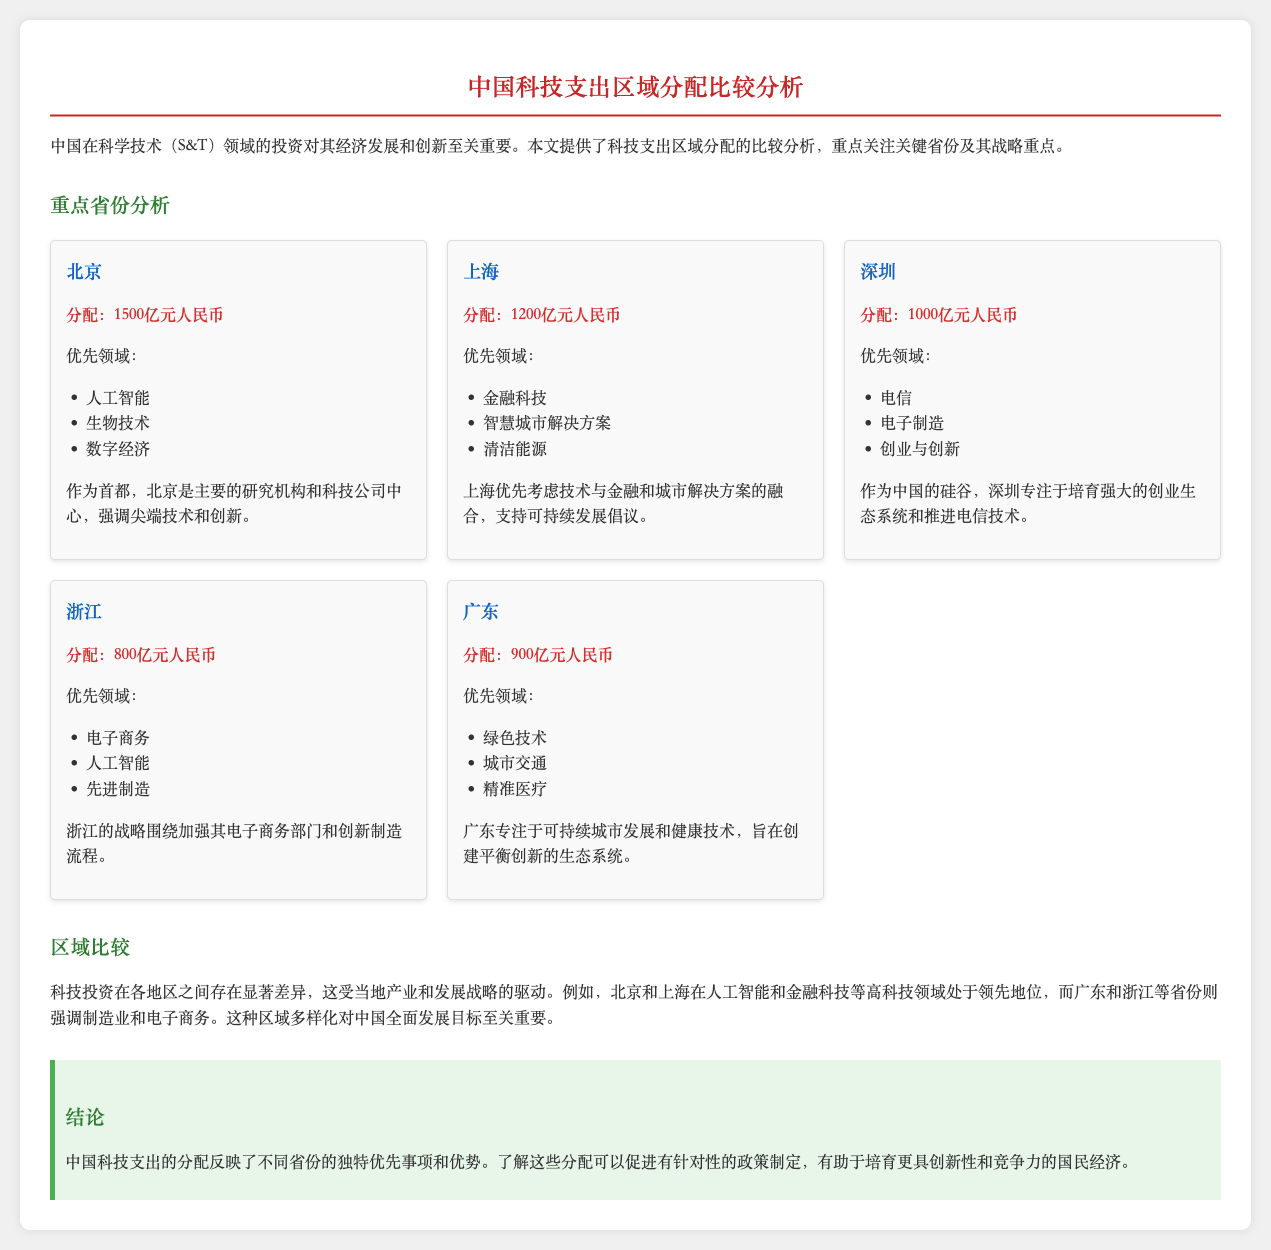What is the science and technology spending in Beijing? The document states that Beijing has an allocation of 1500亿元人民币 for science and technology spending.
Answer: 1500亿元人民币 What are the priority fields for Shanghai? The priority fields listed for Shanghai include financial technology, smart city solutions, and clean energy.
Answer: 金融科技, 智慧城市解决方案, 清洁能源 Which province has the lowest allocated spending? The allocation for Zhejiang is noted as 800亿元人民币, which is the lowest among the mentioned provinces.
Answer: 800亿元人民币 In which province is the focus on telecommunications? The document mentions that Shenzhen focuses on telecommunications among other fields.
Answer: 深圳 How much total allocation is given to Guangdong? The total allocation for Guangdong is stated as 900亿元人民币.
Answer: 900亿元人民币 What is a key area of investment for Shenzhen? The document highlights that a key investment area for Shenzhen is fostering a strong startup ecosystem.
Answer: 创业与创新 Which two provinces are leading in high technology fields like artificial intelligence? The document specifies that Beijing and Shanghai are leading in high-tech fields such as artificial intelligence.
Answer: 北京, 上海 What is a common priority between Guangdong and Shanghai? Both provinces emphasize urban solutions, with Guangdong focusing on urban transport and Shanghai on smart city solutions.
Answer: 城市解决方案 What is the overarching theme of technology spending across regions? The document concludes that the spending reflects unique priorities and advantages of different provinces, indicating a diverse regional focus.
Answer: 区域多样化 